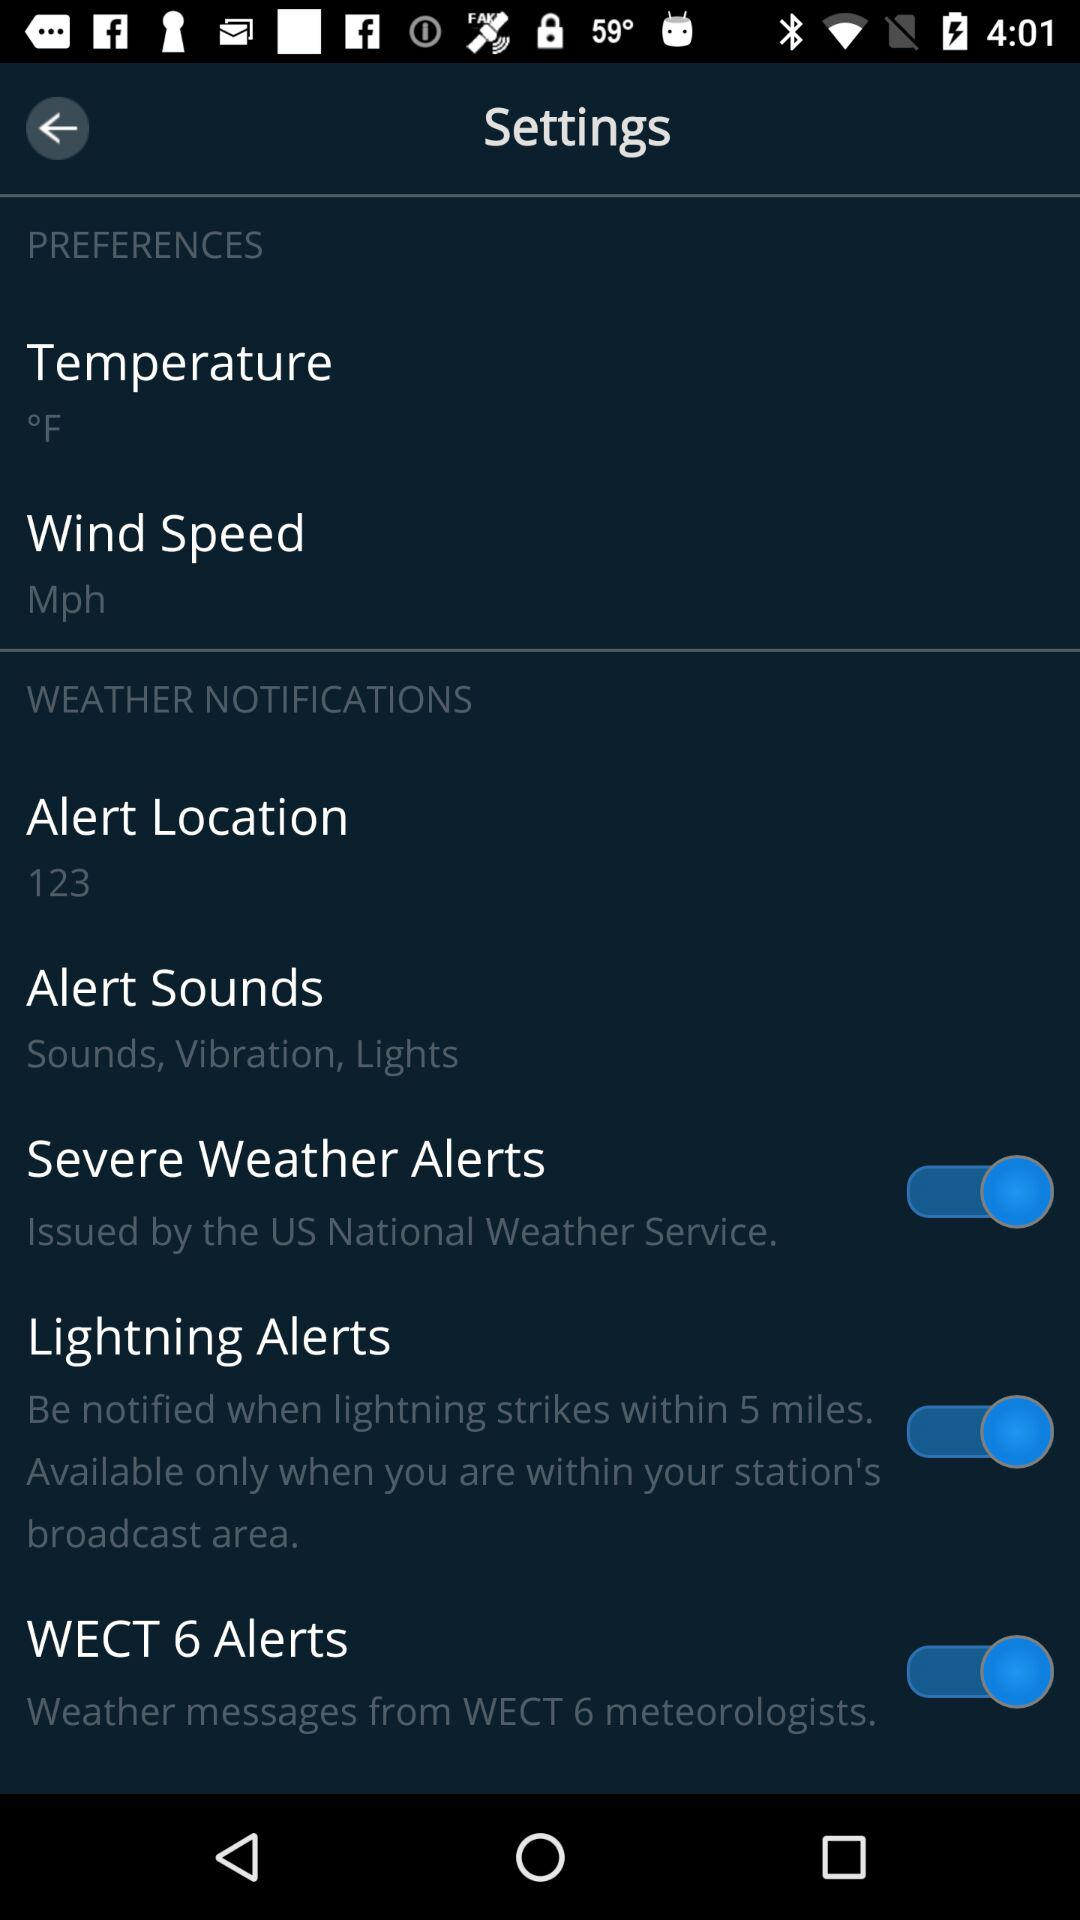In which unit is wind speed measured? Wind speed is measured in mph. 